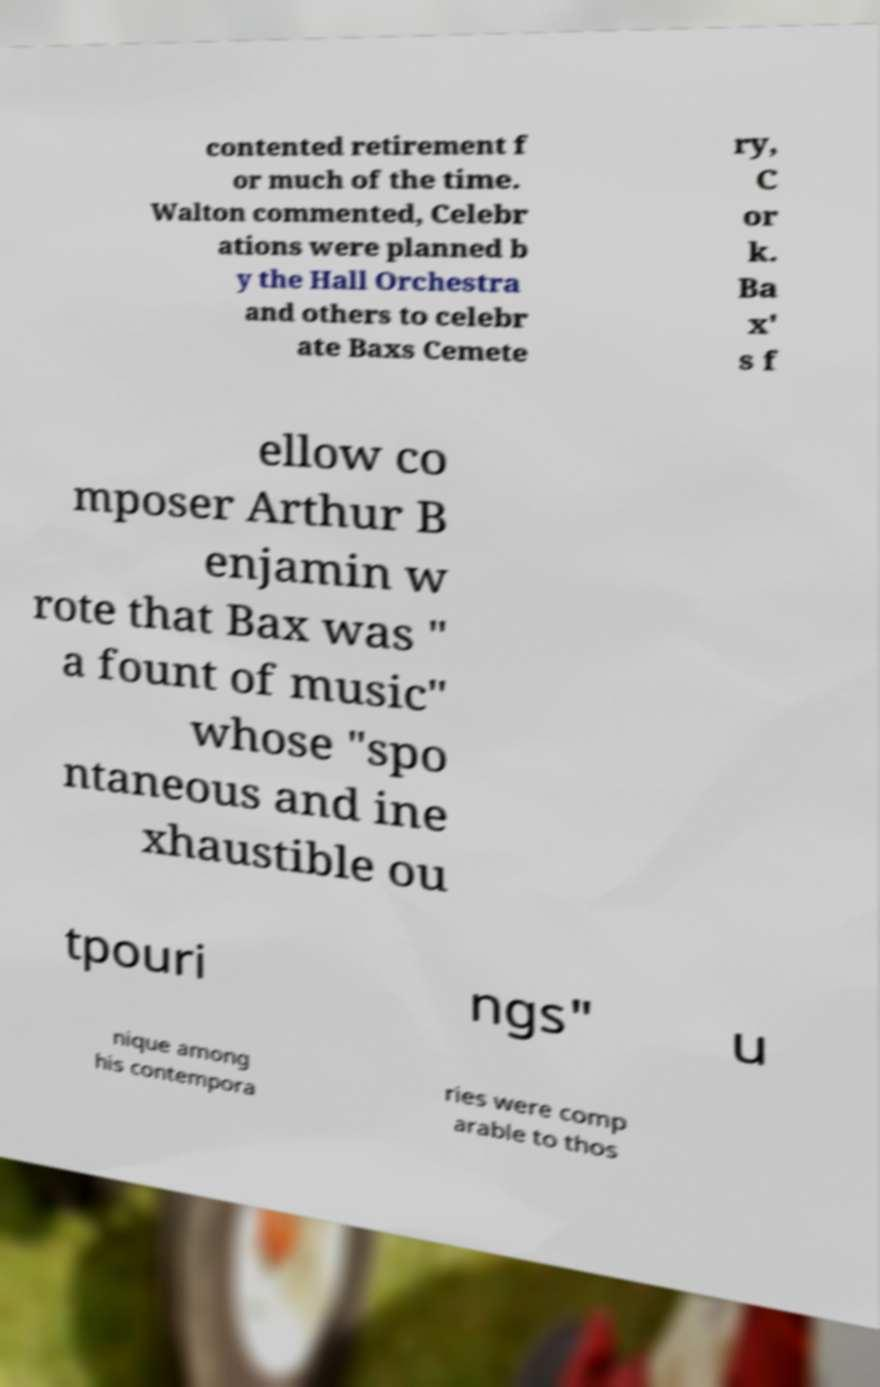Can you accurately transcribe the text from the provided image for me? contented retirement f or much of the time. Walton commented, Celebr ations were planned b y the Hall Orchestra and others to celebr ate Baxs Cemete ry, C or k. Ba x' s f ellow co mposer Arthur B enjamin w rote that Bax was " a fount of music" whose "spo ntaneous and ine xhaustible ou tpouri ngs" u nique among his contempora ries were comp arable to thos 